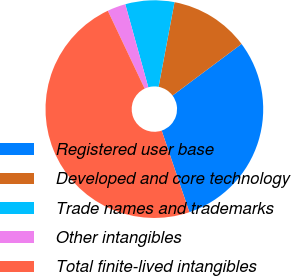Convert chart to OTSL. <chart><loc_0><loc_0><loc_500><loc_500><pie_chart><fcel>Registered user base<fcel>Developed and core technology<fcel>Trade names and trademarks<fcel>Other intangibles<fcel>Total finite-lived intangibles<nl><fcel>30.0%<fcel>11.82%<fcel>7.27%<fcel>2.73%<fcel>48.18%<nl></chart> 